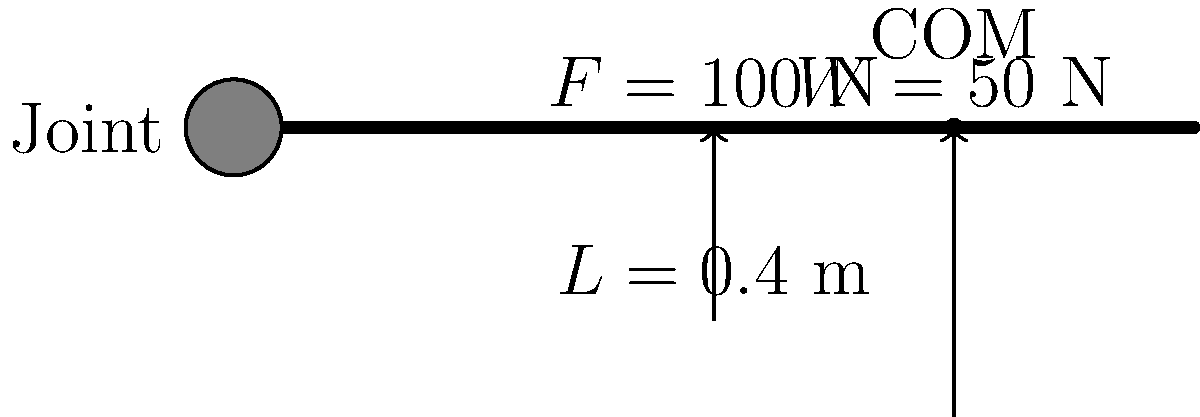Given the free-body diagram of a limb segment above, calculate the joint torque. The force $F$ is applied perpendicular to the limb segment at its distal end, and the weight $W$ acts at the center of mass (COM). The length of the limb segment is $L$, and the COM is located at $3L/4$ from the joint. Assume counterclockwise rotation is positive. To calculate the joint torque, we need to consider the moments created by both the applied force and the weight of the limb segment. Let's break this down step-by-step:

1. Calculate the moment arm for the applied force $F$:
   The force is applied at the distal end, so the moment arm is the full length of the segment.
   Moment arm for $F = L = 0.4$ m

2. Calculate the moment arm for the weight $W$:
   The weight acts at the COM, which is located at $3L/4$ from the joint.
   Moment arm for $W = 3L/4 = 3 * 0.4 / 4 = 0.3$ m

3. Calculate the torque due to the applied force $F$:
   $\tau_F = F * L = 100 \text{ N} * 0.4 \text{ m} = 40 \text{ N}\cdot\text{m}$ (positive, counterclockwise)

4. Calculate the torque due to the weight $W$:
   $\tau_W = W * (3L/4) = 50 \text{ N} * 0.3 \text{ m} = 15 \text{ N}\cdot\text{m}$ (negative, clockwise)

5. Sum the torques to get the net joint torque:
   $\tau_{\text{net}} = \tau_F - \tau_W = 40 \text{ N}\cdot\text{m} - 15 \text{ N}\cdot\text{m} = 25 \text{ N}\cdot\text{m}$

Therefore, the net joint torque is 25 N·m in the counterclockwise direction.
Answer: 25 N·m counterclockwise 